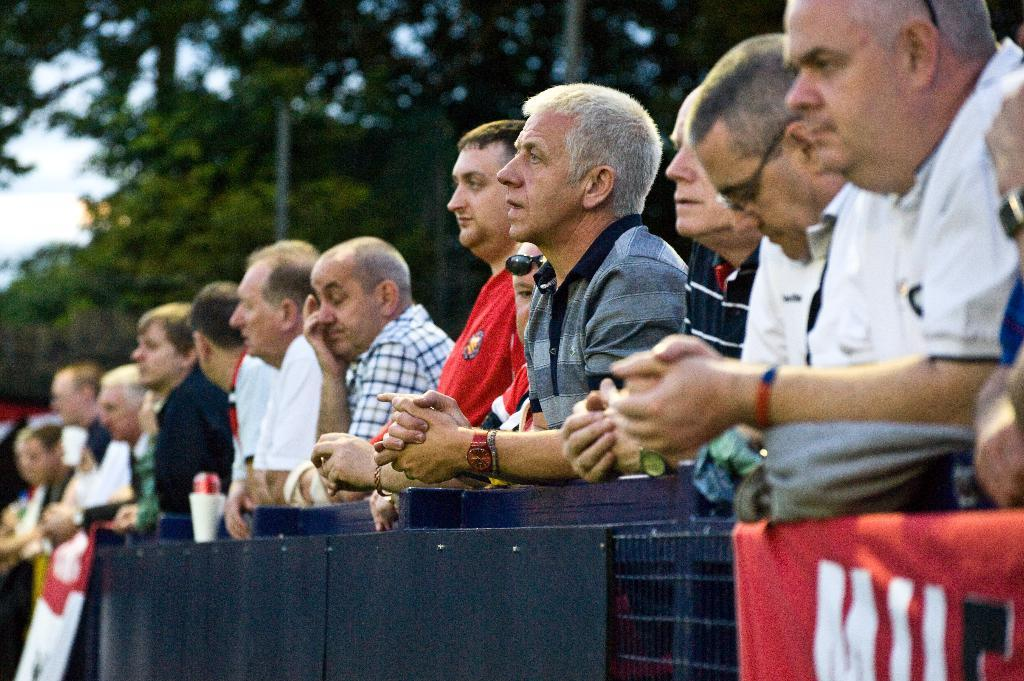What is happening in the center of the image? There are people standing in the center of the image. What can be seen at the bottom of the image? There is a fence and boards at the bottom of the image. What is visible in the background of the image? There are trees and the sky in the background of the image. Where is the river flowing in the image? There is no river present in the image. What type of protest is taking place in the image? There is no protest depicted in the image; it shows people standing and trees in the background. 